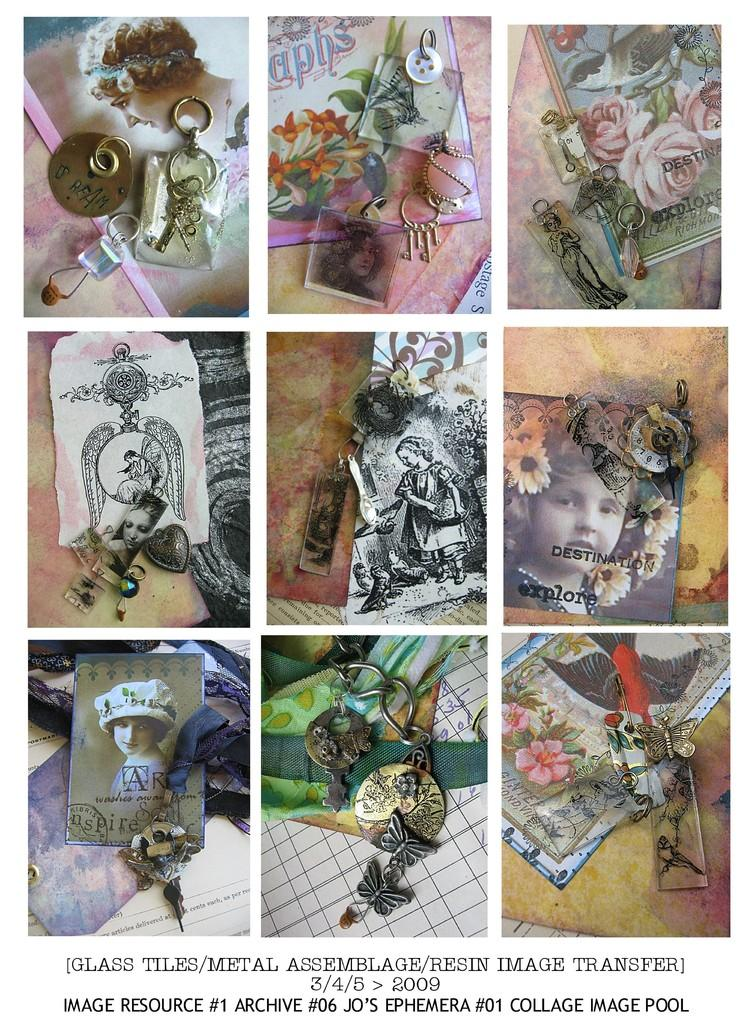How many points are visible on the sheet of paper in the image? There is no sheet of paper or points present in the image. How many bikes are parked next to the tree in the image? There is no tree or bikes present in the image. 